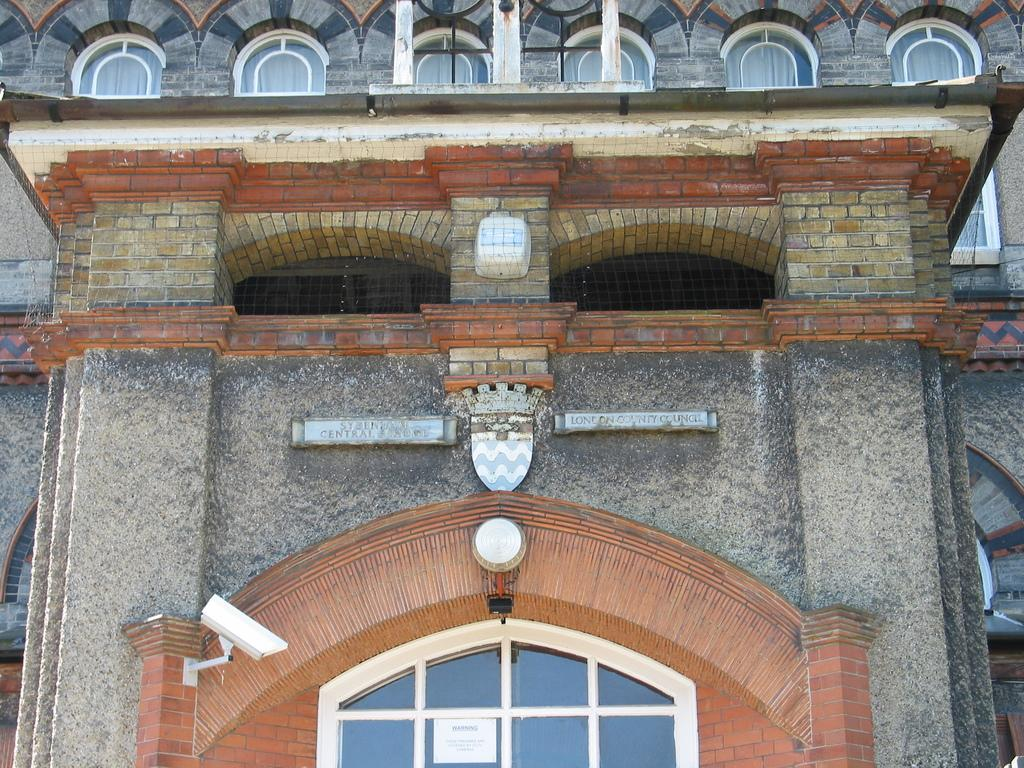What is the main subject of the picture? The main subject of the picture is a building. What type of windows does the building have? The building has glass windows. Can you see a dock near the building during the rainstorm in the image? There is no dock or rainstorm present in the image; it only features a building with glass windows. 